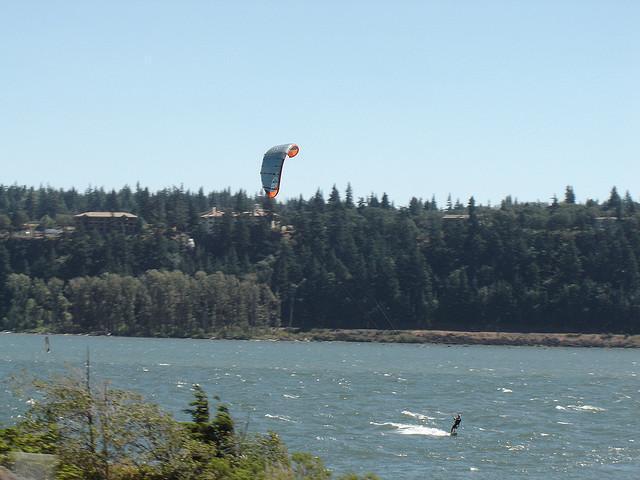How many cats are in the living room?
Give a very brief answer. 0. 